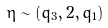<formula> <loc_0><loc_0><loc_500><loc_500>\eta \sim ( q _ { 3 } , 2 , q _ { 1 } )</formula> 